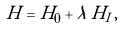<formula> <loc_0><loc_0><loc_500><loc_500>H = H _ { 0 } + \lambda \, H _ { I } \, ,</formula> 